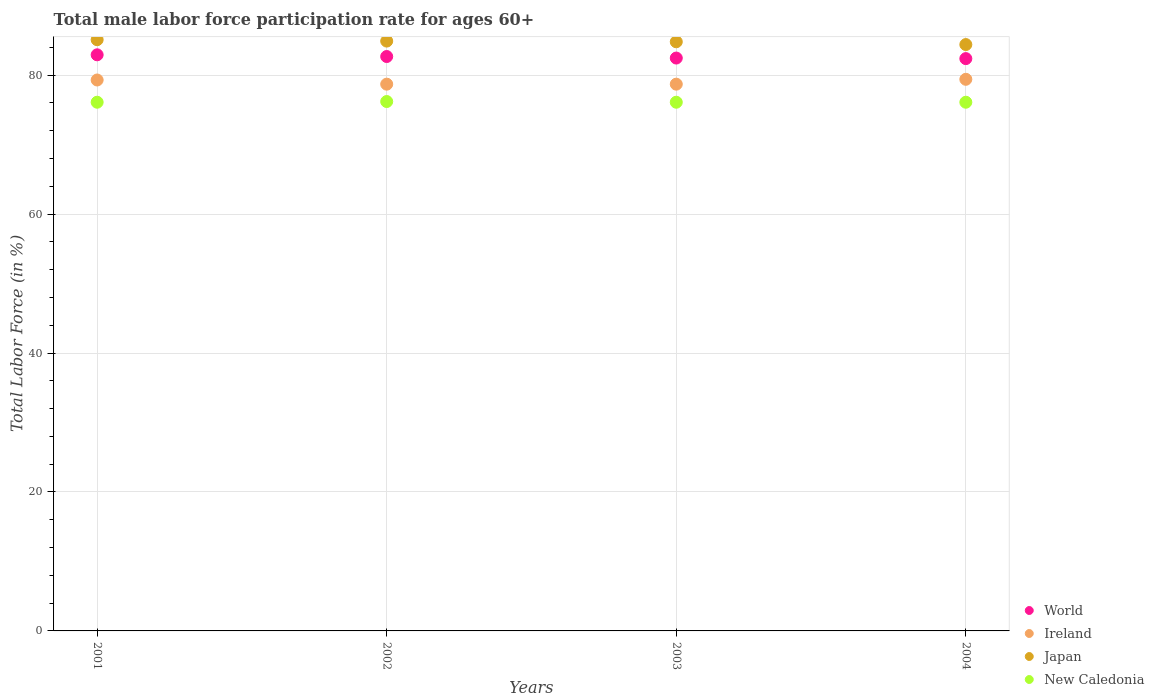What is the male labor force participation rate in World in 2003?
Offer a very short reply. 82.46. Across all years, what is the maximum male labor force participation rate in Ireland?
Ensure brevity in your answer.  79.4. Across all years, what is the minimum male labor force participation rate in World?
Keep it short and to the point. 82.38. In which year was the male labor force participation rate in World maximum?
Give a very brief answer. 2001. What is the total male labor force participation rate in New Caledonia in the graph?
Make the answer very short. 304.5. What is the difference between the male labor force participation rate in Ireland in 2001 and that in 2004?
Provide a succinct answer. -0.1. What is the difference between the male labor force participation rate in Japan in 2004 and the male labor force participation rate in Ireland in 2003?
Provide a short and direct response. 5.7. What is the average male labor force participation rate in World per year?
Your answer should be compact. 82.61. In how many years, is the male labor force participation rate in World greater than 4 %?
Your answer should be compact. 4. What is the ratio of the male labor force participation rate in World in 2003 to that in 2004?
Offer a very short reply. 1. Is the male labor force participation rate in Japan in 2002 less than that in 2004?
Make the answer very short. No. What is the difference between the highest and the second highest male labor force participation rate in World?
Provide a succinct answer. 0.25. What is the difference between the highest and the lowest male labor force participation rate in Japan?
Your answer should be compact. 0.7. In how many years, is the male labor force participation rate in Japan greater than the average male labor force participation rate in Japan taken over all years?
Your answer should be very brief. 3. Is the sum of the male labor force participation rate in Ireland in 2003 and 2004 greater than the maximum male labor force participation rate in Japan across all years?
Keep it short and to the point. Yes. Is it the case that in every year, the sum of the male labor force participation rate in Japan and male labor force participation rate in New Caledonia  is greater than the sum of male labor force participation rate in Ireland and male labor force participation rate in World?
Give a very brief answer. Yes. Is it the case that in every year, the sum of the male labor force participation rate in New Caledonia and male labor force participation rate in Ireland  is greater than the male labor force participation rate in Japan?
Your answer should be very brief. Yes. Is the male labor force participation rate in New Caledonia strictly greater than the male labor force participation rate in World over the years?
Provide a short and direct response. No. Is the male labor force participation rate in Ireland strictly less than the male labor force participation rate in World over the years?
Your response must be concise. Yes. How many years are there in the graph?
Your response must be concise. 4. What is the difference between two consecutive major ticks on the Y-axis?
Offer a terse response. 20. Are the values on the major ticks of Y-axis written in scientific E-notation?
Your answer should be compact. No. Does the graph contain any zero values?
Your answer should be very brief. No. Where does the legend appear in the graph?
Ensure brevity in your answer.  Bottom right. How many legend labels are there?
Your answer should be very brief. 4. How are the legend labels stacked?
Give a very brief answer. Vertical. What is the title of the graph?
Your response must be concise. Total male labor force participation rate for ages 60+. Does "Uzbekistan" appear as one of the legend labels in the graph?
Make the answer very short. No. What is the label or title of the Y-axis?
Offer a very short reply. Total Labor Force (in %). What is the Total Labor Force (in %) in World in 2001?
Ensure brevity in your answer.  82.93. What is the Total Labor Force (in %) in Ireland in 2001?
Ensure brevity in your answer.  79.3. What is the Total Labor Force (in %) in Japan in 2001?
Give a very brief answer. 85.1. What is the Total Labor Force (in %) in New Caledonia in 2001?
Offer a terse response. 76.1. What is the Total Labor Force (in %) in World in 2002?
Give a very brief answer. 82.68. What is the Total Labor Force (in %) in Ireland in 2002?
Give a very brief answer. 78.7. What is the Total Labor Force (in %) in Japan in 2002?
Offer a very short reply. 84.9. What is the Total Labor Force (in %) of New Caledonia in 2002?
Give a very brief answer. 76.2. What is the Total Labor Force (in %) of World in 2003?
Give a very brief answer. 82.46. What is the Total Labor Force (in %) of Ireland in 2003?
Ensure brevity in your answer.  78.7. What is the Total Labor Force (in %) of Japan in 2003?
Provide a succinct answer. 84.8. What is the Total Labor Force (in %) in New Caledonia in 2003?
Give a very brief answer. 76.1. What is the Total Labor Force (in %) of World in 2004?
Keep it short and to the point. 82.38. What is the Total Labor Force (in %) of Ireland in 2004?
Provide a short and direct response. 79.4. What is the Total Labor Force (in %) in Japan in 2004?
Your answer should be compact. 84.4. What is the Total Labor Force (in %) of New Caledonia in 2004?
Provide a succinct answer. 76.1. Across all years, what is the maximum Total Labor Force (in %) in World?
Make the answer very short. 82.93. Across all years, what is the maximum Total Labor Force (in %) of Ireland?
Your response must be concise. 79.4. Across all years, what is the maximum Total Labor Force (in %) of Japan?
Provide a succinct answer. 85.1. Across all years, what is the maximum Total Labor Force (in %) in New Caledonia?
Your response must be concise. 76.2. Across all years, what is the minimum Total Labor Force (in %) of World?
Keep it short and to the point. 82.38. Across all years, what is the minimum Total Labor Force (in %) in Ireland?
Ensure brevity in your answer.  78.7. Across all years, what is the minimum Total Labor Force (in %) of Japan?
Your response must be concise. 84.4. Across all years, what is the minimum Total Labor Force (in %) of New Caledonia?
Your response must be concise. 76.1. What is the total Total Labor Force (in %) of World in the graph?
Your answer should be very brief. 330.44. What is the total Total Labor Force (in %) of Ireland in the graph?
Keep it short and to the point. 316.1. What is the total Total Labor Force (in %) of Japan in the graph?
Provide a short and direct response. 339.2. What is the total Total Labor Force (in %) in New Caledonia in the graph?
Keep it short and to the point. 304.5. What is the difference between the Total Labor Force (in %) of World in 2001 and that in 2002?
Provide a succinct answer. 0.25. What is the difference between the Total Labor Force (in %) of Ireland in 2001 and that in 2002?
Your answer should be compact. 0.6. What is the difference between the Total Labor Force (in %) of Japan in 2001 and that in 2002?
Your answer should be compact. 0.2. What is the difference between the Total Labor Force (in %) of World in 2001 and that in 2003?
Your answer should be compact. 0.47. What is the difference between the Total Labor Force (in %) of Ireland in 2001 and that in 2003?
Your answer should be compact. 0.6. What is the difference between the Total Labor Force (in %) of New Caledonia in 2001 and that in 2003?
Provide a short and direct response. 0. What is the difference between the Total Labor Force (in %) in World in 2001 and that in 2004?
Make the answer very short. 0.55. What is the difference between the Total Labor Force (in %) in World in 2002 and that in 2003?
Your answer should be very brief. 0.22. What is the difference between the Total Labor Force (in %) of Ireland in 2002 and that in 2003?
Provide a short and direct response. 0. What is the difference between the Total Labor Force (in %) of Japan in 2002 and that in 2003?
Provide a succinct answer. 0.1. What is the difference between the Total Labor Force (in %) of World in 2002 and that in 2004?
Keep it short and to the point. 0.3. What is the difference between the Total Labor Force (in %) of Japan in 2002 and that in 2004?
Ensure brevity in your answer.  0.5. What is the difference between the Total Labor Force (in %) of World in 2003 and that in 2004?
Your response must be concise. 0.08. What is the difference between the Total Labor Force (in %) of Japan in 2003 and that in 2004?
Offer a very short reply. 0.4. What is the difference between the Total Labor Force (in %) of World in 2001 and the Total Labor Force (in %) of Ireland in 2002?
Your answer should be compact. 4.23. What is the difference between the Total Labor Force (in %) in World in 2001 and the Total Labor Force (in %) in Japan in 2002?
Give a very brief answer. -1.97. What is the difference between the Total Labor Force (in %) in World in 2001 and the Total Labor Force (in %) in New Caledonia in 2002?
Your answer should be compact. 6.73. What is the difference between the Total Labor Force (in %) of World in 2001 and the Total Labor Force (in %) of Ireland in 2003?
Ensure brevity in your answer.  4.23. What is the difference between the Total Labor Force (in %) in World in 2001 and the Total Labor Force (in %) in Japan in 2003?
Keep it short and to the point. -1.87. What is the difference between the Total Labor Force (in %) in World in 2001 and the Total Labor Force (in %) in New Caledonia in 2003?
Keep it short and to the point. 6.83. What is the difference between the Total Labor Force (in %) in Ireland in 2001 and the Total Labor Force (in %) in Japan in 2003?
Ensure brevity in your answer.  -5.5. What is the difference between the Total Labor Force (in %) of Japan in 2001 and the Total Labor Force (in %) of New Caledonia in 2003?
Provide a succinct answer. 9. What is the difference between the Total Labor Force (in %) of World in 2001 and the Total Labor Force (in %) of Ireland in 2004?
Make the answer very short. 3.53. What is the difference between the Total Labor Force (in %) of World in 2001 and the Total Labor Force (in %) of Japan in 2004?
Your response must be concise. -1.47. What is the difference between the Total Labor Force (in %) of World in 2001 and the Total Labor Force (in %) of New Caledonia in 2004?
Offer a terse response. 6.83. What is the difference between the Total Labor Force (in %) of Ireland in 2001 and the Total Labor Force (in %) of Japan in 2004?
Your answer should be compact. -5.1. What is the difference between the Total Labor Force (in %) of Ireland in 2001 and the Total Labor Force (in %) of New Caledonia in 2004?
Give a very brief answer. 3.2. What is the difference between the Total Labor Force (in %) of Japan in 2001 and the Total Labor Force (in %) of New Caledonia in 2004?
Provide a succinct answer. 9. What is the difference between the Total Labor Force (in %) in World in 2002 and the Total Labor Force (in %) in Ireland in 2003?
Keep it short and to the point. 3.98. What is the difference between the Total Labor Force (in %) of World in 2002 and the Total Labor Force (in %) of Japan in 2003?
Give a very brief answer. -2.12. What is the difference between the Total Labor Force (in %) of World in 2002 and the Total Labor Force (in %) of New Caledonia in 2003?
Keep it short and to the point. 6.58. What is the difference between the Total Labor Force (in %) in Ireland in 2002 and the Total Labor Force (in %) in Japan in 2003?
Your response must be concise. -6.1. What is the difference between the Total Labor Force (in %) of World in 2002 and the Total Labor Force (in %) of Ireland in 2004?
Your answer should be compact. 3.28. What is the difference between the Total Labor Force (in %) of World in 2002 and the Total Labor Force (in %) of Japan in 2004?
Offer a very short reply. -1.72. What is the difference between the Total Labor Force (in %) in World in 2002 and the Total Labor Force (in %) in New Caledonia in 2004?
Keep it short and to the point. 6.58. What is the difference between the Total Labor Force (in %) of World in 2003 and the Total Labor Force (in %) of Ireland in 2004?
Offer a very short reply. 3.06. What is the difference between the Total Labor Force (in %) in World in 2003 and the Total Labor Force (in %) in Japan in 2004?
Provide a succinct answer. -1.94. What is the difference between the Total Labor Force (in %) in World in 2003 and the Total Labor Force (in %) in New Caledonia in 2004?
Your response must be concise. 6.36. What is the difference between the Total Labor Force (in %) of Japan in 2003 and the Total Labor Force (in %) of New Caledonia in 2004?
Offer a terse response. 8.7. What is the average Total Labor Force (in %) in World per year?
Give a very brief answer. 82.61. What is the average Total Labor Force (in %) of Ireland per year?
Provide a succinct answer. 79.03. What is the average Total Labor Force (in %) of Japan per year?
Your answer should be compact. 84.8. What is the average Total Labor Force (in %) in New Caledonia per year?
Provide a succinct answer. 76.12. In the year 2001, what is the difference between the Total Labor Force (in %) of World and Total Labor Force (in %) of Ireland?
Make the answer very short. 3.63. In the year 2001, what is the difference between the Total Labor Force (in %) of World and Total Labor Force (in %) of Japan?
Offer a terse response. -2.17. In the year 2001, what is the difference between the Total Labor Force (in %) of World and Total Labor Force (in %) of New Caledonia?
Your answer should be compact. 6.83. In the year 2001, what is the difference between the Total Labor Force (in %) in Ireland and Total Labor Force (in %) in Japan?
Offer a very short reply. -5.8. In the year 2002, what is the difference between the Total Labor Force (in %) in World and Total Labor Force (in %) in Ireland?
Your answer should be compact. 3.98. In the year 2002, what is the difference between the Total Labor Force (in %) of World and Total Labor Force (in %) of Japan?
Keep it short and to the point. -2.22. In the year 2002, what is the difference between the Total Labor Force (in %) of World and Total Labor Force (in %) of New Caledonia?
Offer a very short reply. 6.48. In the year 2002, what is the difference between the Total Labor Force (in %) of Ireland and Total Labor Force (in %) of Japan?
Your response must be concise. -6.2. In the year 2002, what is the difference between the Total Labor Force (in %) of Ireland and Total Labor Force (in %) of New Caledonia?
Give a very brief answer. 2.5. In the year 2003, what is the difference between the Total Labor Force (in %) in World and Total Labor Force (in %) in Ireland?
Offer a very short reply. 3.76. In the year 2003, what is the difference between the Total Labor Force (in %) of World and Total Labor Force (in %) of Japan?
Provide a succinct answer. -2.34. In the year 2003, what is the difference between the Total Labor Force (in %) of World and Total Labor Force (in %) of New Caledonia?
Keep it short and to the point. 6.36. In the year 2004, what is the difference between the Total Labor Force (in %) of World and Total Labor Force (in %) of Ireland?
Provide a succinct answer. 2.98. In the year 2004, what is the difference between the Total Labor Force (in %) in World and Total Labor Force (in %) in Japan?
Offer a terse response. -2.02. In the year 2004, what is the difference between the Total Labor Force (in %) of World and Total Labor Force (in %) of New Caledonia?
Offer a very short reply. 6.28. What is the ratio of the Total Labor Force (in %) in Ireland in 2001 to that in 2002?
Offer a terse response. 1.01. What is the ratio of the Total Labor Force (in %) in Ireland in 2001 to that in 2003?
Provide a short and direct response. 1.01. What is the ratio of the Total Labor Force (in %) in Japan in 2001 to that in 2003?
Offer a terse response. 1. What is the ratio of the Total Labor Force (in %) in World in 2001 to that in 2004?
Provide a short and direct response. 1.01. What is the ratio of the Total Labor Force (in %) in Ireland in 2001 to that in 2004?
Ensure brevity in your answer.  1. What is the ratio of the Total Labor Force (in %) of Japan in 2001 to that in 2004?
Your response must be concise. 1.01. What is the ratio of the Total Labor Force (in %) in New Caledonia in 2001 to that in 2004?
Ensure brevity in your answer.  1. What is the ratio of the Total Labor Force (in %) of World in 2002 to that in 2004?
Your answer should be very brief. 1. What is the ratio of the Total Labor Force (in %) in Japan in 2002 to that in 2004?
Your response must be concise. 1.01. What is the ratio of the Total Labor Force (in %) of New Caledonia in 2002 to that in 2004?
Your answer should be compact. 1. What is the ratio of the Total Labor Force (in %) in World in 2003 to that in 2004?
Provide a short and direct response. 1. What is the ratio of the Total Labor Force (in %) in Ireland in 2003 to that in 2004?
Make the answer very short. 0.99. What is the ratio of the Total Labor Force (in %) of Japan in 2003 to that in 2004?
Provide a succinct answer. 1. What is the ratio of the Total Labor Force (in %) in New Caledonia in 2003 to that in 2004?
Your answer should be compact. 1. What is the difference between the highest and the second highest Total Labor Force (in %) of World?
Make the answer very short. 0.25. What is the difference between the highest and the second highest Total Labor Force (in %) of Ireland?
Provide a short and direct response. 0.1. What is the difference between the highest and the lowest Total Labor Force (in %) in World?
Your response must be concise. 0.55. What is the difference between the highest and the lowest Total Labor Force (in %) in Japan?
Ensure brevity in your answer.  0.7. What is the difference between the highest and the lowest Total Labor Force (in %) of New Caledonia?
Make the answer very short. 0.1. 